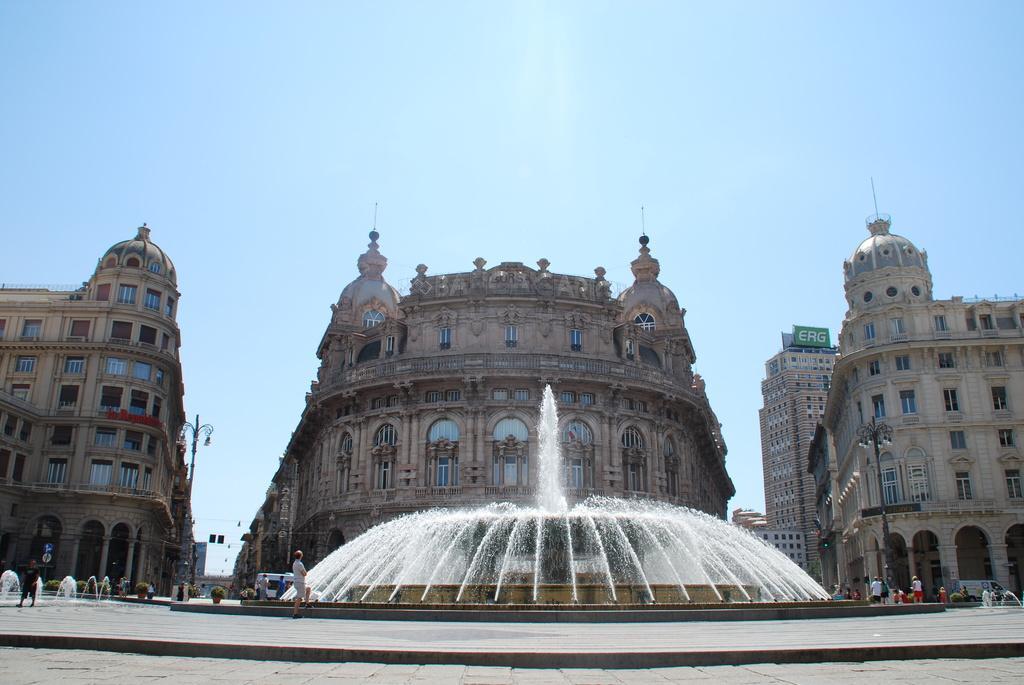Describe this image in one or two sentences. In this picture I can see the path in front and I can see the fountains, number of people and few plants. In the middle of this picture I can see the light poles and number of buildings. In the background I can see the clear sky. I can also see few vehicles. 